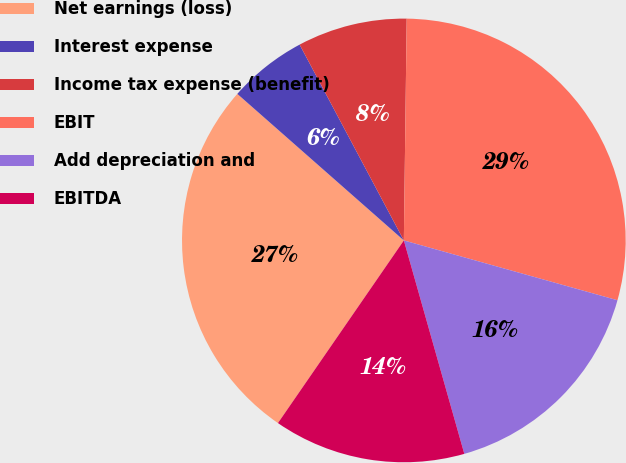<chart> <loc_0><loc_0><loc_500><loc_500><pie_chart><fcel>Net earnings (loss)<fcel>Interest expense<fcel>Income tax expense (benefit)<fcel>EBIT<fcel>Add depreciation and<fcel>EBITDA<nl><fcel>26.88%<fcel>5.73%<fcel>7.99%<fcel>29.14%<fcel>16.26%<fcel>14.0%<nl></chart> 